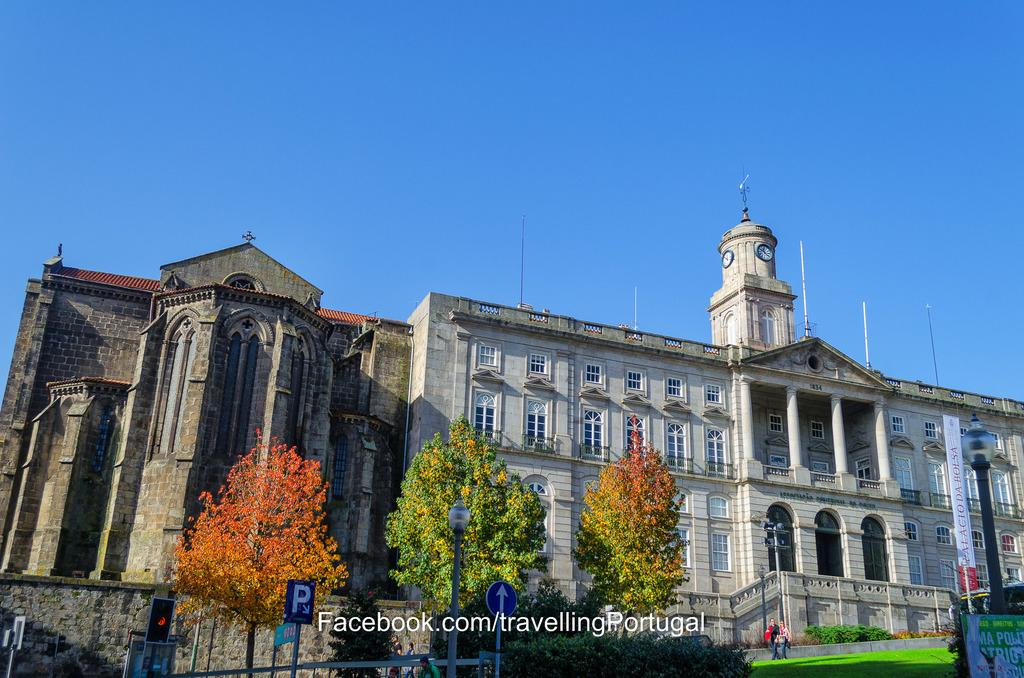<image>
Describe the image concisely. The beautiful Palaciode da Bolsa is in Portugal. 